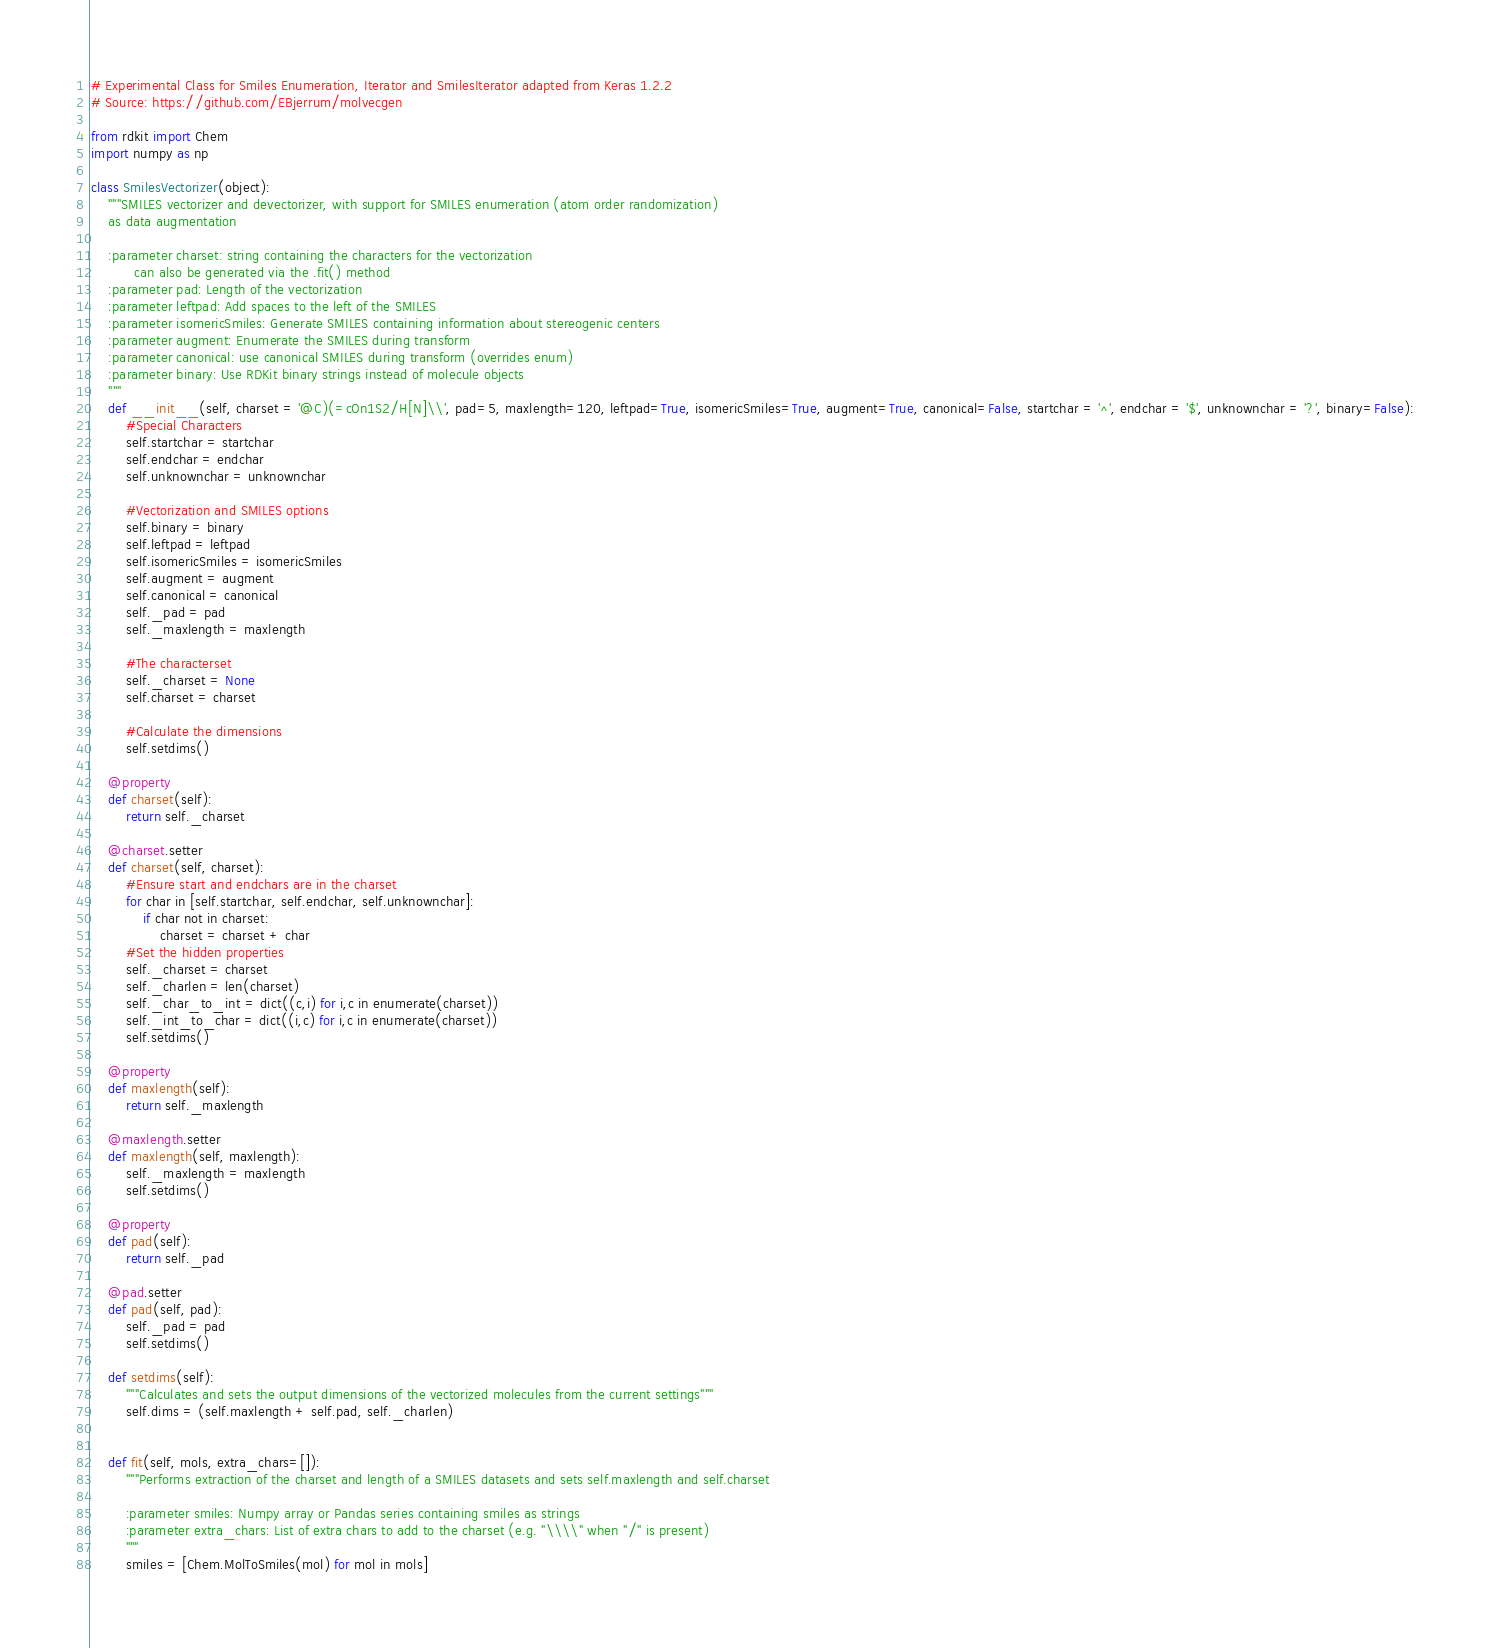Convert code to text. <code><loc_0><loc_0><loc_500><loc_500><_Python_># Experimental Class for Smiles Enumeration, Iterator and SmilesIterator adapted from Keras 1.2.2
# Source: https://github.com/EBjerrum/molvecgen

from rdkit import Chem
import numpy as np

class SmilesVectorizer(object):
    """SMILES vectorizer and devectorizer, with support for SMILES enumeration (atom order randomization)
    as data augmentation
    
    :parameter charset: string containing the characters for the vectorization
          can also be generated via the .fit() method
    :parameter pad: Length of the vectorization
    :parameter leftpad: Add spaces to the left of the SMILES
    :parameter isomericSmiles: Generate SMILES containing information about stereogenic centers
    :parameter augment: Enumerate the SMILES during transform
    :parameter canonical: use canonical SMILES during transform (overrides enum)
    :parameter binary: Use RDKit binary strings instead of molecule objects
    """
    def __init__(self, charset = '@C)(=cOn1S2/H[N]\\', pad=5, maxlength=120, leftpad=True, isomericSmiles=True, augment=True, canonical=False, startchar = '^', endchar = '$', unknownchar = '?', binary=False):
        #Special Characters
        self.startchar = startchar
        self.endchar = endchar
        self.unknownchar = unknownchar
        
        #Vectorization and SMILES options
        self.binary = binary
        self.leftpad = leftpad
        self.isomericSmiles = isomericSmiles
        self.augment = augment
        self.canonical = canonical
        self._pad = pad
        self._maxlength = maxlength
        
        #The characterset
        self._charset = None
        self.charset = charset
        
        #Calculate the dimensions
        self.setdims()

    @property
    def charset(self):
        return self._charset
        
    @charset.setter
    def charset(self, charset):
        #Ensure start and endchars are in the charset
        for char in [self.startchar, self.endchar, self.unknownchar]:
            if char not in charset:
                charset = charset + char
        #Set the hidden properties        
        self._charset = charset
        self._charlen = len(charset)
        self._char_to_int = dict((c,i) for i,c in enumerate(charset))
        self._int_to_char = dict((i,c) for i,c in enumerate(charset))
        self.setdims()
        
    @property
    def maxlength(self):
        return self._maxlength
    
    @maxlength.setter
    def maxlength(self, maxlength):
        self._maxlength = maxlength
        self.setdims()
        
    @property
    def pad(self):
        return self._pad
    
    @pad.setter
    def pad(self, pad):
        self._pad = pad
        self.setdims()
        
    def setdims(self):
        """Calculates and sets the output dimensions of the vectorized molecules from the current settings"""
        self.dims = (self.maxlength + self.pad, self._charlen)
    
        
    def fit(self, mols, extra_chars=[]):
        """Performs extraction of the charset and length of a SMILES datasets and sets self.maxlength and self.charset
        
        :parameter smiles: Numpy array or Pandas series containing smiles as strings
        :parameter extra_chars: List of extra chars to add to the charset (e.g. "\\\\" when "/" is present)
        """
        smiles = [Chem.MolToSmiles(mol) for mol in mols]</code> 